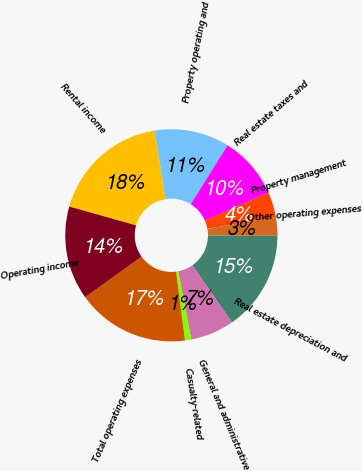Convert chart. <chart><loc_0><loc_0><loc_500><loc_500><pie_chart><fcel>Rental income<fcel>Property operating and<fcel>Real estate taxes and<fcel>Property management<fcel>Other operating expenses<fcel>Real estate depreciation and<fcel>General and administrative<fcel>Casualty-related<fcel>Total operating expenses<fcel>Operating income<nl><fcel>18.1%<fcel>11.43%<fcel>9.52%<fcel>3.81%<fcel>2.86%<fcel>15.24%<fcel>6.67%<fcel>0.95%<fcel>17.14%<fcel>14.29%<nl></chart> 